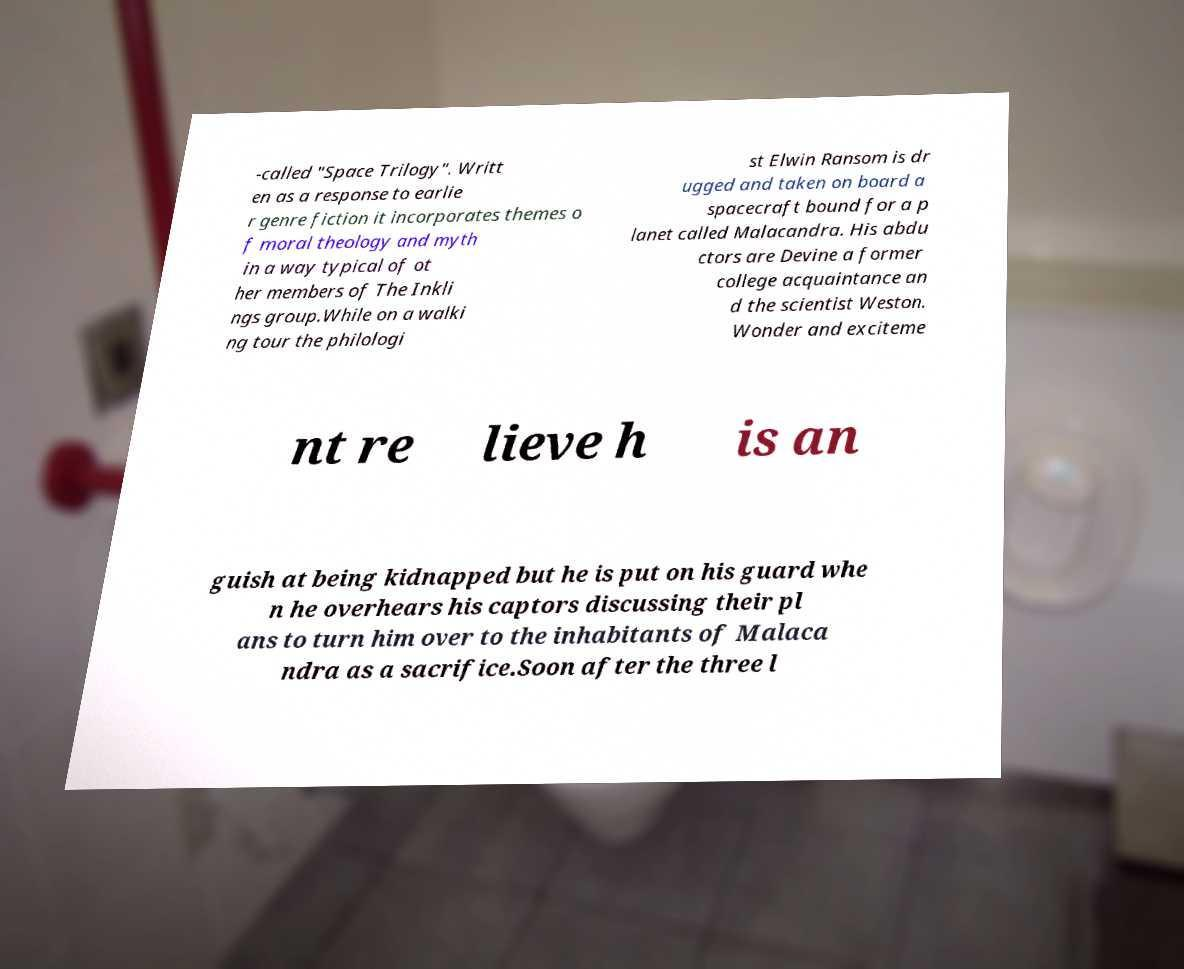There's text embedded in this image that I need extracted. Can you transcribe it verbatim? -called "Space Trilogy". Writt en as a response to earlie r genre fiction it incorporates themes o f moral theology and myth in a way typical of ot her members of The Inkli ngs group.While on a walki ng tour the philologi st Elwin Ransom is dr ugged and taken on board a spacecraft bound for a p lanet called Malacandra. His abdu ctors are Devine a former college acquaintance an d the scientist Weston. Wonder and exciteme nt re lieve h is an guish at being kidnapped but he is put on his guard whe n he overhears his captors discussing their pl ans to turn him over to the inhabitants of Malaca ndra as a sacrifice.Soon after the three l 